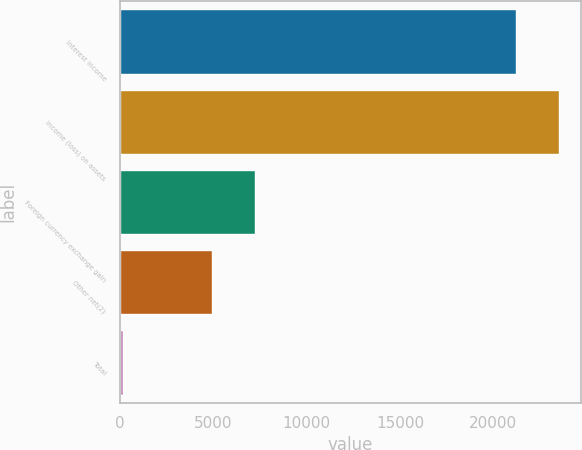Convert chart to OTSL. <chart><loc_0><loc_0><loc_500><loc_500><bar_chart><fcel>Interest income<fcel>Income (loss) on assets<fcel>Foreign currency exchange gain<fcel>Other net(2)<fcel>Total<nl><fcel>21211<fcel>23503.7<fcel>7224.7<fcel>4932<fcel>156<nl></chart> 